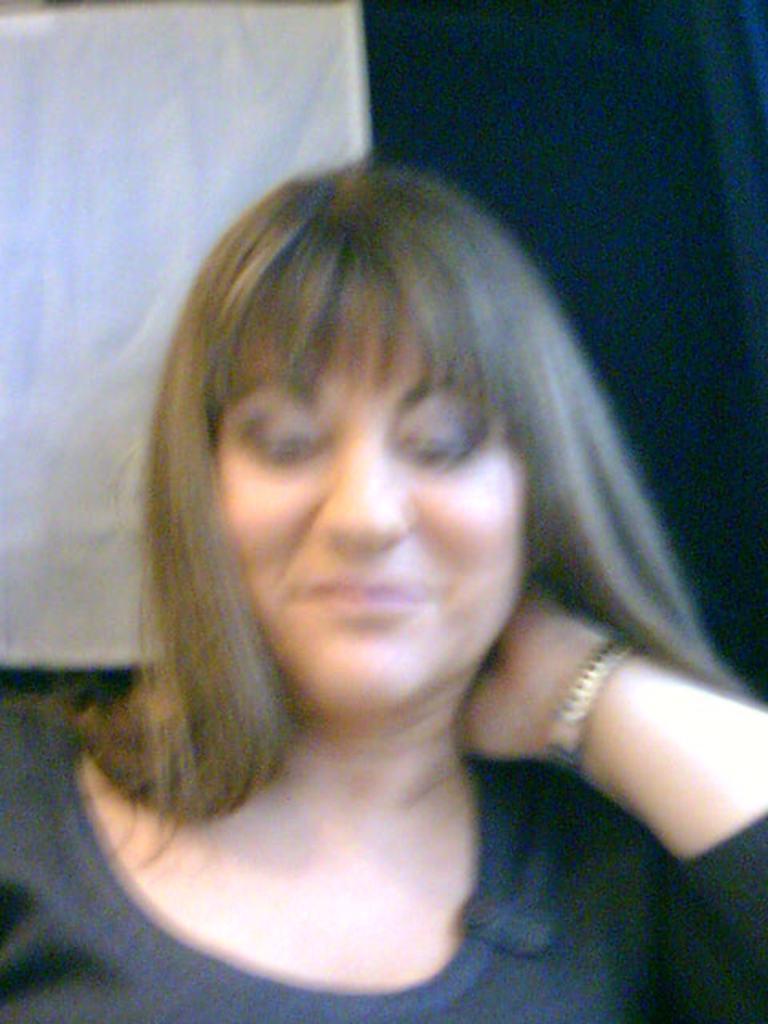How would you summarize this image in a sentence or two? It is the blur image of a woman. In the background there is a curtain. 